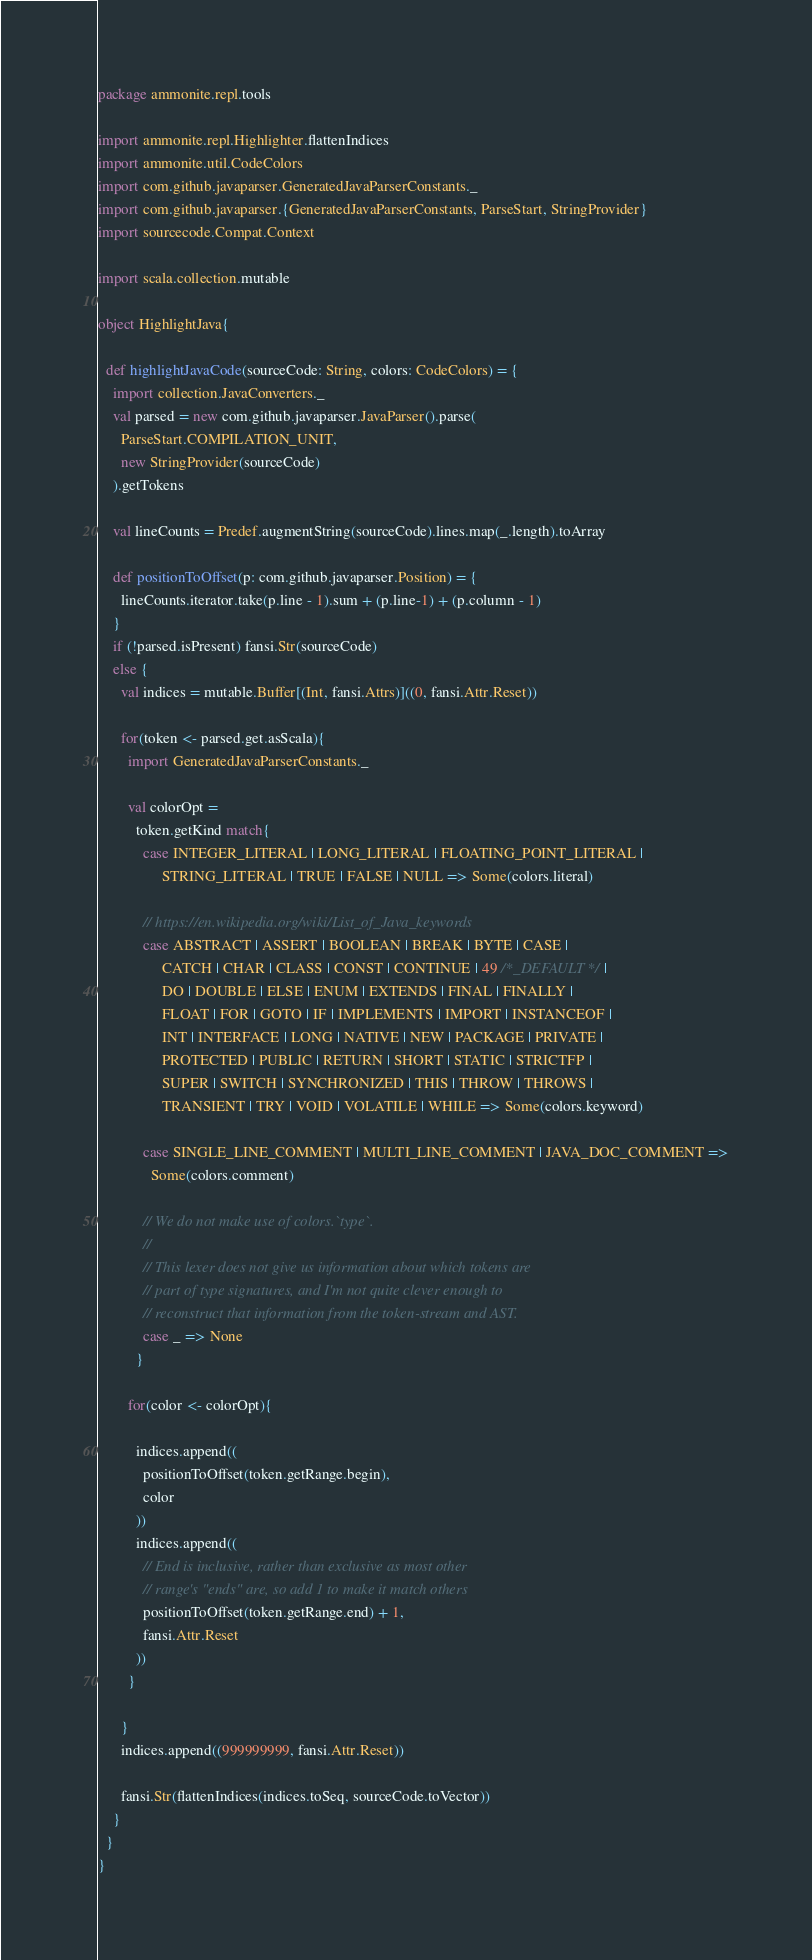<code> <loc_0><loc_0><loc_500><loc_500><_Scala_>package ammonite.repl.tools

import ammonite.repl.Highlighter.flattenIndices
import ammonite.util.CodeColors
import com.github.javaparser.GeneratedJavaParserConstants._
import com.github.javaparser.{GeneratedJavaParserConstants, ParseStart, StringProvider}
import sourcecode.Compat.Context

import scala.collection.mutable

object HighlightJava{

  def highlightJavaCode(sourceCode: String, colors: CodeColors) = {
    import collection.JavaConverters._
    val parsed = new com.github.javaparser.JavaParser().parse(
      ParseStart.COMPILATION_UNIT,
      new StringProvider(sourceCode)
    ).getTokens

    val lineCounts = Predef.augmentString(sourceCode).lines.map(_.length).toArray

    def positionToOffset(p: com.github.javaparser.Position) = {
      lineCounts.iterator.take(p.line - 1).sum + (p.line-1) + (p.column - 1)
    }
    if (!parsed.isPresent) fansi.Str(sourceCode)
    else {
      val indices = mutable.Buffer[(Int, fansi.Attrs)]((0, fansi.Attr.Reset))

      for(token <- parsed.get.asScala){
        import GeneratedJavaParserConstants._

        val colorOpt =
          token.getKind match{
            case INTEGER_LITERAL | LONG_LITERAL | FLOATING_POINT_LITERAL |
                 STRING_LITERAL | TRUE | FALSE | NULL => Some(colors.literal)

            // https://en.wikipedia.org/wiki/List_of_Java_keywords
            case ABSTRACT | ASSERT | BOOLEAN | BREAK | BYTE | CASE |
                 CATCH | CHAR | CLASS | CONST | CONTINUE | 49 /*_DEFAULT*/ |
                 DO | DOUBLE | ELSE | ENUM | EXTENDS | FINAL | FINALLY |
                 FLOAT | FOR | GOTO | IF | IMPLEMENTS | IMPORT | INSTANCEOF |
                 INT | INTERFACE | LONG | NATIVE | NEW | PACKAGE | PRIVATE |
                 PROTECTED | PUBLIC | RETURN | SHORT | STATIC | STRICTFP |
                 SUPER | SWITCH | SYNCHRONIZED | THIS | THROW | THROWS |
                 TRANSIENT | TRY | VOID | VOLATILE | WHILE => Some(colors.keyword)

            case SINGLE_LINE_COMMENT | MULTI_LINE_COMMENT | JAVA_DOC_COMMENT =>
              Some(colors.comment)

            // We do not make use of colors.`type`.
            //
            // This lexer does not give us information about which tokens are
            // part of type signatures, and I'm not quite clever enough to
            // reconstruct that information from the token-stream and AST.
            case _ => None
          }

        for(color <- colorOpt){

          indices.append((
            positionToOffset(token.getRange.begin),
            color
          ))
          indices.append((
            // End is inclusive, rather than exclusive as most other
            // range's "ends" are, so add 1 to make it match others
            positionToOffset(token.getRange.end) + 1,
            fansi.Attr.Reset
          ))
        }

      }
      indices.append((999999999, fansi.Attr.Reset))

      fansi.Str(flattenIndices(indices.toSeq, sourceCode.toVector))
    }
  }
}</code> 